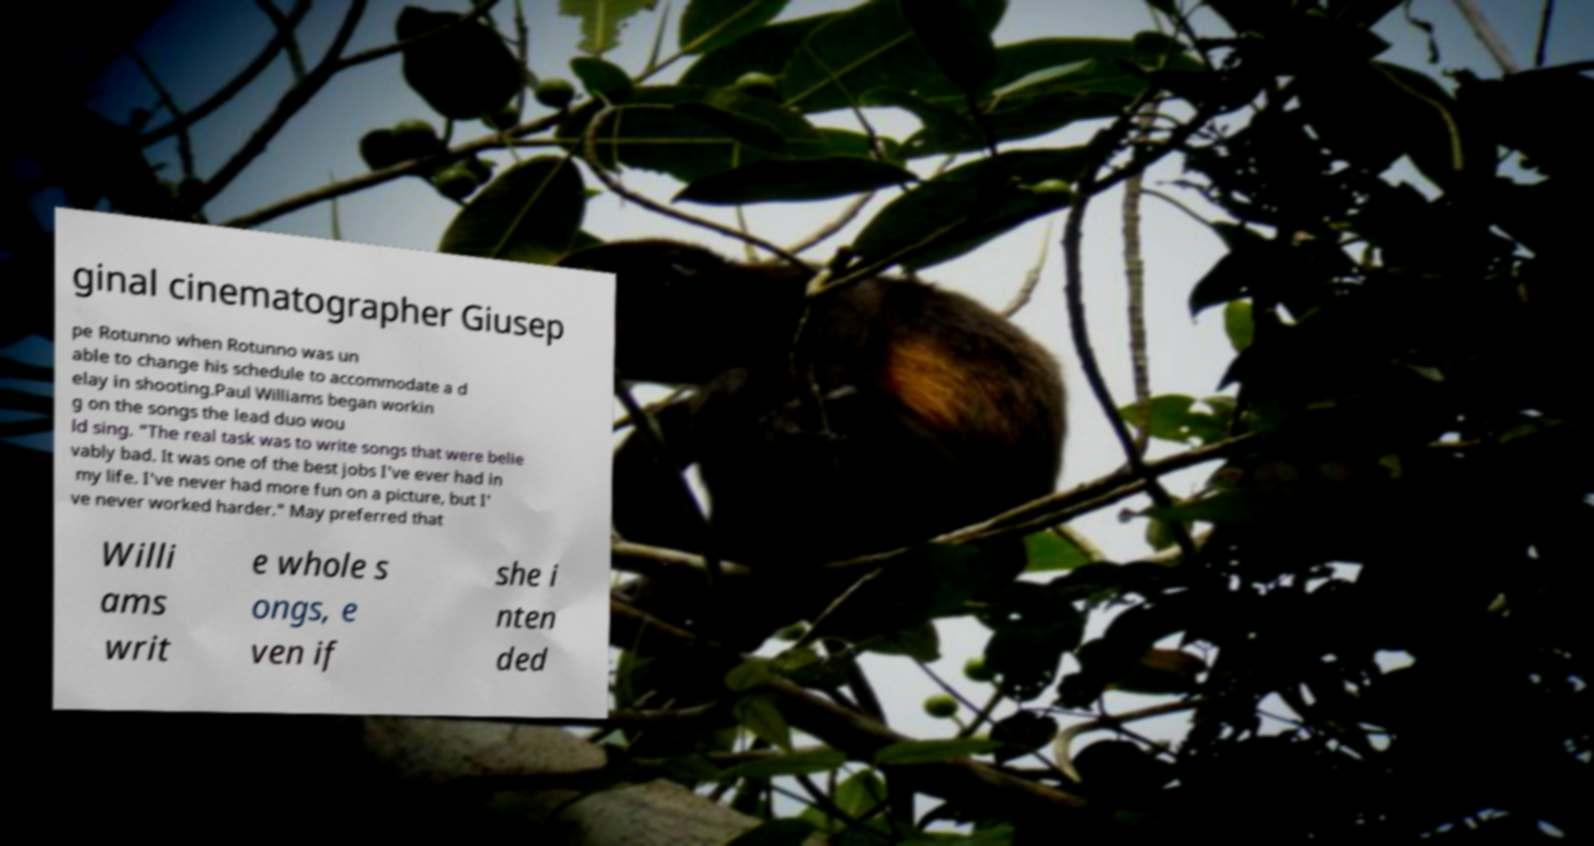Can you accurately transcribe the text from the provided image for me? ginal cinematographer Giusep pe Rotunno when Rotunno was un able to change his schedule to accommodate a d elay in shooting.Paul Williams began workin g on the songs the lead duo wou ld sing. "The real task was to write songs that were belie vably bad. It was one of the best jobs I've ever had in my life. I've never had more fun on a picture, but I' ve never worked harder." May preferred that Willi ams writ e whole s ongs, e ven if she i nten ded 